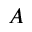Convert formula to latex. <formula><loc_0><loc_0><loc_500><loc_500>A</formula> 